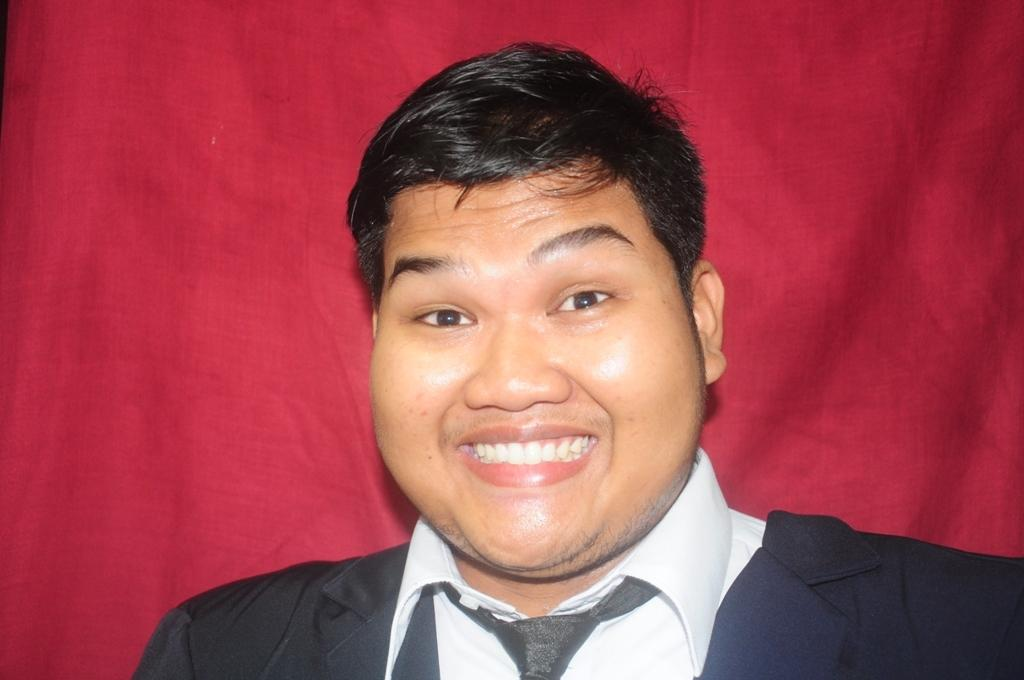What is the man in the image doing? The man is standing in the image. What expression does the man have? The man is smiling. What can be seen in the background of the image? There is a red curtain in the background of the image. What type of food is the man holding in the image? There is no food present in the image; the man is simply standing and smiling. 